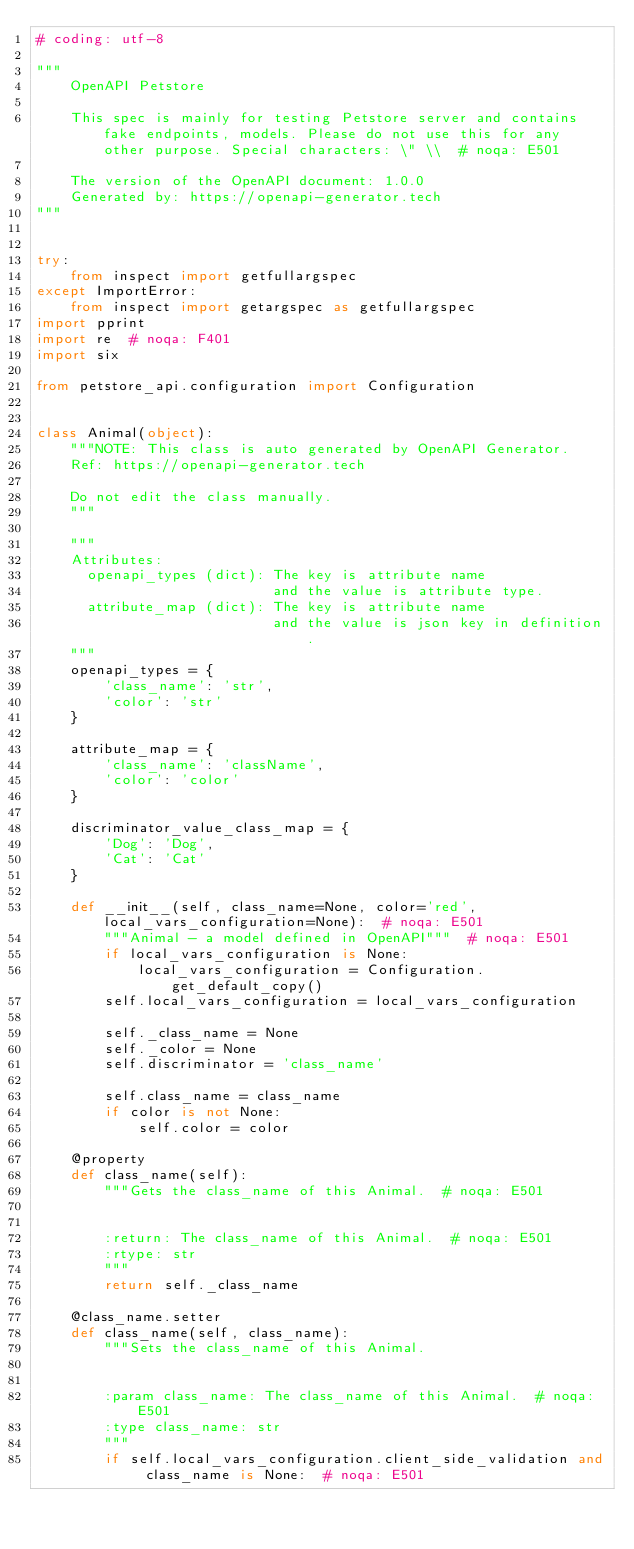<code> <loc_0><loc_0><loc_500><loc_500><_Python_># coding: utf-8

"""
    OpenAPI Petstore

    This spec is mainly for testing Petstore server and contains fake endpoints, models. Please do not use this for any other purpose. Special characters: \" \\  # noqa: E501

    The version of the OpenAPI document: 1.0.0
    Generated by: https://openapi-generator.tech
"""


try:
    from inspect import getfullargspec
except ImportError:
    from inspect import getargspec as getfullargspec
import pprint
import re  # noqa: F401
import six

from petstore_api.configuration import Configuration


class Animal(object):
    """NOTE: This class is auto generated by OpenAPI Generator.
    Ref: https://openapi-generator.tech

    Do not edit the class manually.
    """

    """
    Attributes:
      openapi_types (dict): The key is attribute name
                            and the value is attribute type.
      attribute_map (dict): The key is attribute name
                            and the value is json key in definition.
    """
    openapi_types = {
        'class_name': 'str',
        'color': 'str'
    }

    attribute_map = {
        'class_name': 'className',
        'color': 'color'
    }

    discriminator_value_class_map = {
        'Dog': 'Dog',
        'Cat': 'Cat'
    }

    def __init__(self, class_name=None, color='red', local_vars_configuration=None):  # noqa: E501
        """Animal - a model defined in OpenAPI"""  # noqa: E501
        if local_vars_configuration is None:
            local_vars_configuration = Configuration.get_default_copy()
        self.local_vars_configuration = local_vars_configuration

        self._class_name = None
        self._color = None
        self.discriminator = 'class_name'

        self.class_name = class_name
        if color is not None:
            self.color = color

    @property
    def class_name(self):
        """Gets the class_name of this Animal.  # noqa: E501


        :return: The class_name of this Animal.  # noqa: E501
        :rtype: str
        """
        return self._class_name

    @class_name.setter
    def class_name(self, class_name):
        """Sets the class_name of this Animal.


        :param class_name: The class_name of this Animal.  # noqa: E501
        :type class_name: str
        """
        if self.local_vars_configuration.client_side_validation and class_name is None:  # noqa: E501</code> 